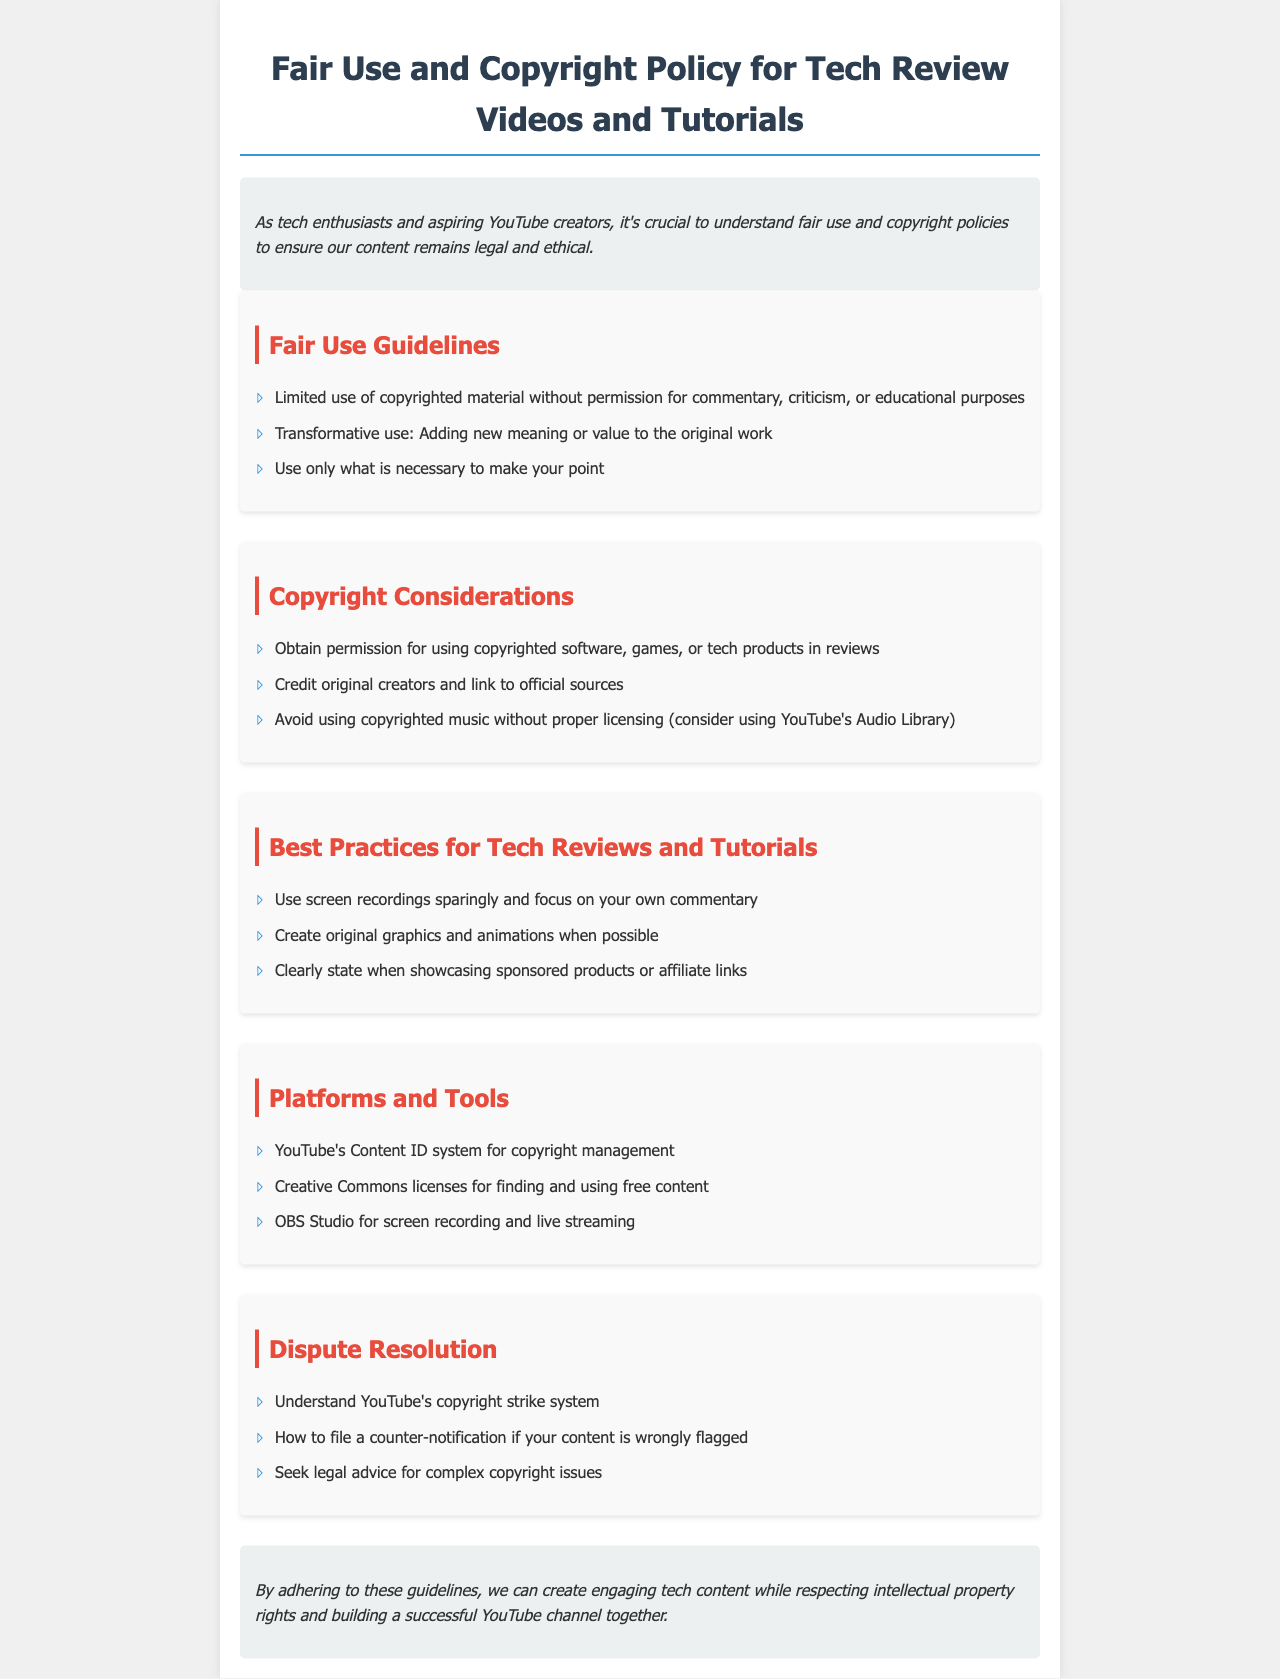What are the fair use guidelines? The fair use guidelines outline the limited use of copyrighted material for specific purposes and include points about transformative use and necessity.
Answer: Limited use of copyrighted material without permission for commentary, criticism, or educational purposes What is required for obtaining copyright permission? The document states that permission for using copyrighted software, games, or tech products in reviews should be obtained explicitly.
Answer: Obtain permission for using copyrighted software, games, or tech products in reviews What should be done with copyrighted music? The policy advises avoiding the use of copyrighted music without proper licensing and suggests an alternative.
Answer: Avoid using copyrighted music without proper licensing What practices should be employed in tech reviews? Best practices listed include using screen recordings sparingly and creating original graphics whenever possible.
Answer: Use screen recordings sparingly and focus on your own commentary What tool is mentioned for copyright management? A platform or system included in the document that helps with managing copyright issues on videos is specified.
Answer: YouTube's Content ID system for copyright management How does the document suggest addressing copyright strikes? The document covers dispute resolution methods, hinting at the necessity to understand specific systems related to copyright.
Answer: Understand YouTube's copyright strike system What should be clearly stated when showcasing products? The policy mentions a requirement regarding transparency when featuring certain products in content.
Answer: Clearly state when showcasing sponsored products or affiliate links 